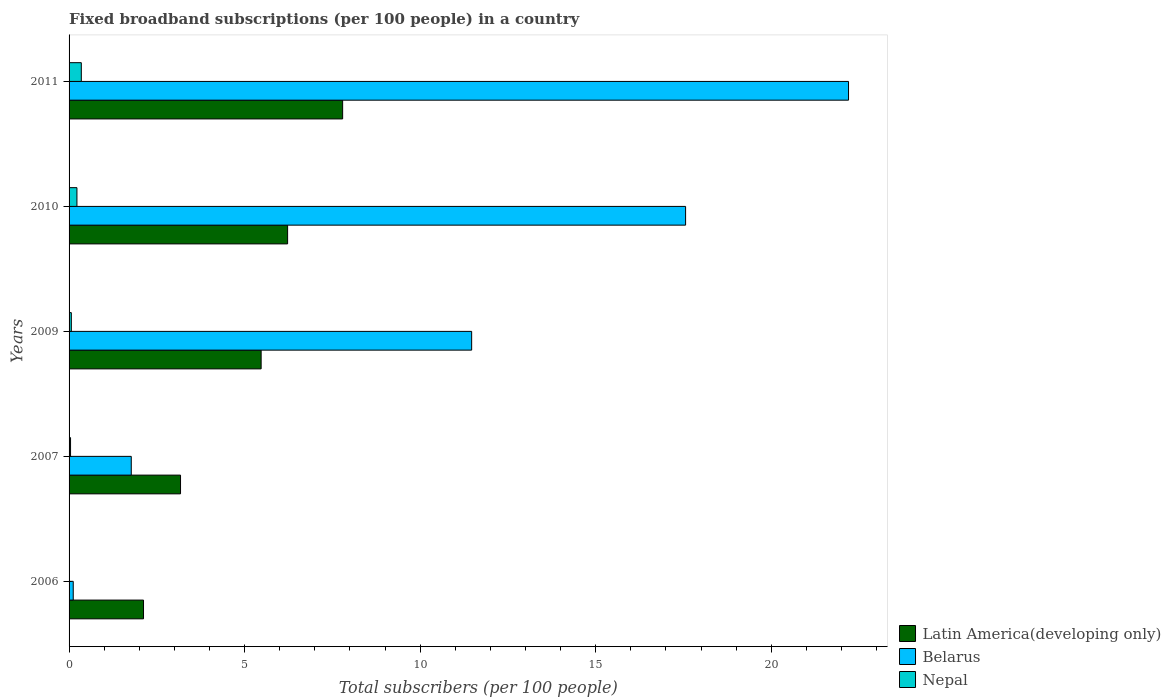How many groups of bars are there?
Ensure brevity in your answer.  5. How many bars are there on the 1st tick from the bottom?
Keep it short and to the point. 3. What is the label of the 5th group of bars from the top?
Ensure brevity in your answer.  2006. What is the number of broadband subscriptions in Nepal in 2011?
Keep it short and to the point. 0.35. Across all years, what is the maximum number of broadband subscriptions in Latin America(developing only)?
Give a very brief answer. 7.79. Across all years, what is the minimum number of broadband subscriptions in Nepal?
Make the answer very short. 0. In which year was the number of broadband subscriptions in Nepal minimum?
Give a very brief answer. 2006. What is the total number of broadband subscriptions in Latin America(developing only) in the graph?
Provide a short and direct response. 24.78. What is the difference between the number of broadband subscriptions in Latin America(developing only) in 2007 and that in 2009?
Your answer should be compact. -2.3. What is the difference between the number of broadband subscriptions in Belarus in 2010 and the number of broadband subscriptions in Nepal in 2006?
Offer a terse response. 17.56. What is the average number of broadband subscriptions in Belarus per year?
Your response must be concise. 10.62. In the year 2006, what is the difference between the number of broadband subscriptions in Belarus and number of broadband subscriptions in Nepal?
Your answer should be compact. 0.11. What is the ratio of the number of broadband subscriptions in Belarus in 2006 to that in 2011?
Ensure brevity in your answer.  0.01. What is the difference between the highest and the second highest number of broadband subscriptions in Latin America(developing only)?
Your answer should be compact. 1.57. What is the difference between the highest and the lowest number of broadband subscriptions in Nepal?
Your response must be concise. 0.34. In how many years, is the number of broadband subscriptions in Latin America(developing only) greater than the average number of broadband subscriptions in Latin America(developing only) taken over all years?
Your response must be concise. 3. What does the 1st bar from the top in 2010 represents?
Your answer should be very brief. Nepal. What does the 3rd bar from the bottom in 2010 represents?
Provide a succinct answer. Nepal. How many years are there in the graph?
Make the answer very short. 5. Are the values on the major ticks of X-axis written in scientific E-notation?
Offer a very short reply. No. Does the graph contain any zero values?
Make the answer very short. No. How many legend labels are there?
Offer a terse response. 3. How are the legend labels stacked?
Provide a short and direct response. Vertical. What is the title of the graph?
Your answer should be very brief. Fixed broadband subscriptions (per 100 people) in a country. What is the label or title of the X-axis?
Your answer should be compact. Total subscribers (per 100 people). What is the Total subscribers (per 100 people) in Latin America(developing only) in 2006?
Your answer should be very brief. 2.12. What is the Total subscribers (per 100 people) in Belarus in 2006?
Your answer should be very brief. 0.12. What is the Total subscribers (per 100 people) in Nepal in 2006?
Your response must be concise. 0. What is the Total subscribers (per 100 people) in Latin America(developing only) in 2007?
Your response must be concise. 3.17. What is the Total subscribers (per 100 people) in Belarus in 2007?
Offer a very short reply. 1.77. What is the Total subscribers (per 100 people) of Nepal in 2007?
Ensure brevity in your answer.  0.04. What is the Total subscribers (per 100 people) of Latin America(developing only) in 2009?
Your response must be concise. 5.47. What is the Total subscribers (per 100 people) of Belarus in 2009?
Provide a short and direct response. 11.47. What is the Total subscribers (per 100 people) in Nepal in 2009?
Ensure brevity in your answer.  0.06. What is the Total subscribers (per 100 people) of Latin America(developing only) in 2010?
Offer a terse response. 6.22. What is the Total subscribers (per 100 people) of Belarus in 2010?
Offer a very short reply. 17.56. What is the Total subscribers (per 100 people) in Nepal in 2010?
Provide a short and direct response. 0.22. What is the Total subscribers (per 100 people) in Latin America(developing only) in 2011?
Offer a terse response. 7.79. What is the Total subscribers (per 100 people) of Belarus in 2011?
Make the answer very short. 22.2. What is the Total subscribers (per 100 people) of Nepal in 2011?
Provide a succinct answer. 0.35. Across all years, what is the maximum Total subscribers (per 100 people) of Latin America(developing only)?
Keep it short and to the point. 7.79. Across all years, what is the maximum Total subscribers (per 100 people) in Belarus?
Offer a terse response. 22.2. Across all years, what is the maximum Total subscribers (per 100 people) in Nepal?
Provide a short and direct response. 0.35. Across all years, what is the minimum Total subscribers (per 100 people) in Latin America(developing only)?
Your response must be concise. 2.12. Across all years, what is the minimum Total subscribers (per 100 people) in Belarus?
Your answer should be compact. 0.12. Across all years, what is the minimum Total subscribers (per 100 people) in Nepal?
Make the answer very short. 0. What is the total Total subscribers (per 100 people) of Latin America(developing only) in the graph?
Make the answer very short. 24.78. What is the total Total subscribers (per 100 people) of Belarus in the graph?
Your answer should be compact. 53.12. What is the total Total subscribers (per 100 people) of Nepal in the graph?
Provide a short and direct response. 0.68. What is the difference between the Total subscribers (per 100 people) of Latin America(developing only) in 2006 and that in 2007?
Your response must be concise. -1.05. What is the difference between the Total subscribers (per 100 people) of Belarus in 2006 and that in 2007?
Your answer should be very brief. -1.65. What is the difference between the Total subscribers (per 100 people) of Nepal in 2006 and that in 2007?
Your response must be concise. -0.04. What is the difference between the Total subscribers (per 100 people) of Latin America(developing only) in 2006 and that in 2009?
Keep it short and to the point. -3.35. What is the difference between the Total subscribers (per 100 people) of Belarus in 2006 and that in 2009?
Provide a short and direct response. -11.35. What is the difference between the Total subscribers (per 100 people) of Nepal in 2006 and that in 2009?
Your answer should be very brief. -0.06. What is the difference between the Total subscribers (per 100 people) of Latin America(developing only) in 2006 and that in 2010?
Make the answer very short. -4.1. What is the difference between the Total subscribers (per 100 people) in Belarus in 2006 and that in 2010?
Offer a terse response. -17.44. What is the difference between the Total subscribers (per 100 people) of Nepal in 2006 and that in 2010?
Your response must be concise. -0.22. What is the difference between the Total subscribers (per 100 people) of Latin America(developing only) in 2006 and that in 2011?
Make the answer very short. -5.67. What is the difference between the Total subscribers (per 100 people) of Belarus in 2006 and that in 2011?
Keep it short and to the point. -22.08. What is the difference between the Total subscribers (per 100 people) in Nepal in 2006 and that in 2011?
Ensure brevity in your answer.  -0.34. What is the difference between the Total subscribers (per 100 people) in Latin America(developing only) in 2007 and that in 2009?
Your answer should be compact. -2.3. What is the difference between the Total subscribers (per 100 people) of Belarus in 2007 and that in 2009?
Ensure brevity in your answer.  -9.7. What is the difference between the Total subscribers (per 100 people) of Nepal in 2007 and that in 2009?
Offer a very short reply. -0.02. What is the difference between the Total subscribers (per 100 people) in Latin America(developing only) in 2007 and that in 2010?
Your response must be concise. -3.05. What is the difference between the Total subscribers (per 100 people) of Belarus in 2007 and that in 2010?
Your answer should be compact. -15.79. What is the difference between the Total subscribers (per 100 people) in Nepal in 2007 and that in 2010?
Your answer should be very brief. -0.18. What is the difference between the Total subscribers (per 100 people) of Latin America(developing only) in 2007 and that in 2011?
Ensure brevity in your answer.  -4.62. What is the difference between the Total subscribers (per 100 people) of Belarus in 2007 and that in 2011?
Keep it short and to the point. -20.43. What is the difference between the Total subscribers (per 100 people) in Nepal in 2007 and that in 2011?
Offer a terse response. -0.31. What is the difference between the Total subscribers (per 100 people) in Latin America(developing only) in 2009 and that in 2010?
Offer a very short reply. -0.75. What is the difference between the Total subscribers (per 100 people) in Belarus in 2009 and that in 2010?
Provide a short and direct response. -6.09. What is the difference between the Total subscribers (per 100 people) in Nepal in 2009 and that in 2010?
Give a very brief answer. -0.16. What is the difference between the Total subscribers (per 100 people) in Latin America(developing only) in 2009 and that in 2011?
Make the answer very short. -2.32. What is the difference between the Total subscribers (per 100 people) in Belarus in 2009 and that in 2011?
Keep it short and to the point. -10.73. What is the difference between the Total subscribers (per 100 people) in Nepal in 2009 and that in 2011?
Keep it short and to the point. -0.28. What is the difference between the Total subscribers (per 100 people) in Latin America(developing only) in 2010 and that in 2011?
Your response must be concise. -1.57. What is the difference between the Total subscribers (per 100 people) of Belarus in 2010 and that in 2011?
Your answer should be compact. -4.64. What is the difference between the Total subscribers (per 100 people) in Nepal in 2010 and that in 2011?
Offer a terse response. -0.12. What is the difference between the Total subscribers (per 100 people) in Latin America(developing only) in 2006 and the Total subscribers (per 100 people) in Belarus in 2007?
Ensure brevity in your answer.  0.35. What is the difference between the Total subscribers (per 100 people) in Latin America(developing only) in 2006 and the Total subscribers (per 100 people) in Nepal in 2007?
Your response must be concise. 2.08. What is the difference between the Total subscribers (per 100 people) in Belarus in 2006 and the Total subscribers (per 100 people) in Nepal in 2007?
Provide a short and direct response. 0.08. What is the difference between the Total subscribers (per 100 people) of Latin America(developing only) in 2006 and the Total subscribers (per 100 people) of Belarus in 2009?
Give a very brief answer. -9.35. What is the difference between the Total subscribers (per 100 people) of Latin America(developing only) in 2006 and the Total subscribers (per 100 people) of Nepal in 2009?
Your response must be concise. 2.06. What is the difference between the Total subscribers (per 100 people) of Belarus in 2006 and the Total subscribers (per 100 people) of Nepal in 2009?
Provide a short and direct response. 0.05. What is the difference between the Total subscribers (per 100 people) in Latin America(developing only) in 2006 and the Total subscribers (per 100 people) in Belarus in 2010?
Keep it short and to the point. -15.44. What is the difference between the Total subscribers (per 100 people) in Latin America(developing only) in 2006 and the Total subscribers (per 100 people) in Nepal in 2010?
Offer a terse response. 1.9. What is the difference between the Total subscribers (per 100 people) of Belarus in 2006 and the Total subscribers (per 100 people) of Nepal in 2010?
Provide a short and direct response. -0.11. What is the difference between the Total subscribers (per 100 people) in Latin America(developing only) in 2006 and the Total subscribers (per 100 people) in Belarus in 2011?
Offer a terse response. -20.08. What is the difference between the Total subscribers (per 100 people) of Latin America(developing only) in 2006 and the Total subscribers (per 100 people) of Nepal in 2011?
Provide a succinct answer. 1.77. What is the difference between the Total subscribers (per 100 people) in Belarus in 2006 and the Total subscribers (per 100 people) in Nepal in 2011?
Your response must be concise. -0.23. What is the difference between the Total subscribers (per 100 people) of Latin America(developing only) in 2007 and the Total subscribers (per 100 people) of Belarus in 2009?
Your answer should be compact. -8.29. What is the difference between the Total subscribers (per 100 people) of Latin America(developing only) in 2007 and the Total subscribers (per 100 people) of Nepal in 2009?
Give a very brief answer. 3.11. What is the difference between the Total subscribers (per 100 people) of Belarus in 2007 and the Total subscribers (per 100 people) of Nepal in 2009?
Provide a short and direct response. 1.71. What is the difference between the Total subscribers (per 100 people) in Latin America(developing only) in 2007 and the Total subscribers (per 100 people) in Belarus in 2010?
Provide a succinct answer. -14.39. What is the difference between the Total subscribers (per 100 people) in Latin America(developing only) in 2007 and the Total subscribers (per 100 people) in Nepal in 2010?
Make the answer very short. 2.95. What is the difference between the Total subscribers (per 100 people) in Belarus in 2007 and the Total subscribers (per 100 people) in Nepal in 2010?
Keep it short and to the point. 1.55. What is the difference between the Total subscribers (per 100 people) in Latin America(developing only) in 2007 and the Total subscribers (per 100 people) in Belarus in 2011?
Your response must be concise. -19.03. What is the difference between the Total subscribers (per 100 people) of Latin America(developing only) in 2007 and the Total subscribers (per 100 people) of Nepal in 2011?
Make the answer very short. 2.83. What is the difference between the Total subscribers (per 100 people) in Belarus in 2007 and the Total subscribers (per 100 people) in Nepal in 2011?
Your response must be concise. 1.42. What is the difference between the Total subscribers (per 100 people) of Latin America(developing only) in 2009 and the Total subscribers (per 100 people) of Belarus in 2010?
Make the answer very short. -12.09. What is the difference between the Total subscribers (per 100 people) in Latin America(developing only) in 2009 and the Total subscribers (per 100 people) in Nepal in 2010?
Provide a short and direct response. 5.25. What is the difference between the Total subscribers (per 100 people) in Belarus in 2009 and the Total subscribers (per 100 people) in Nepal in 2010?
Your response must be concise. 11.24. What is the difference between the Total subscribers (per 100 people) in Latin America(developing only) in 2009 and the Total subscribers (per 100 people) in Belarus in 2011?
Make the answer very short. -16.73. What is the difference between the Total subscribers (per 100 people) in Latin America(developing only) in 2009 and the Total subscribers (per 100 people) in Nepal in 2011?
Provide a short and direct response. 5.12. What is the difference between the Total subscribers (per 100 people) of Belarus in 2009 and the Total subscribers (per 100 people) of Nepal in 2011?
Provide a short and direct response. 11.12. What is the difference between the Total subscribers (per 100 people) in Latin America(developing only) in 2010 and the Total subscribers (per 100 people) in Belarus in 2011?
Offer a terse response. -15.98. What is the difference between the Total subscribers (per 100 people) in Latin America(developing only) in 2010 and the Total subscribers (per 100 people) in Nepal in 2011?
Keep it short and to the point. 5.88. What is the difference between the Total subscribers (per 100 people) in Belarus in 2010 and the Total subscribers (per 100 people) in Nepal in 2011?
Provide a succinct answer. 17.21. What is the average Total subscribers (per 100 people) of Latin America(developing only) per year?
Offer a very short reply. 4.96. What is the average Total subscribers (per 100 people) of Belarus per year?
Give a very brief answer. 10.62. What is the average Total subscribers (per 100 people) in Nepal per year?
Make the answer very short. 0.14. In the year 2006, what is the difference between the Total subscribers (per 100 people) in Latin America(developing only) and Total subscribers (per 100 people) in Belarus?
Ensure brevity in your answer.  2. In the year 2006, what is the difference between the Total subscribers (per 100 people) of Latin America(developing only) and Total subscribers (per 100 people) of Nepal?
Offer a terse response. 2.12. In the year 2006, what is the difference between the Total subscribers (per 100 people) of Belarus and Total subscribers (per 100 people) of Nepal?
Your answer should be very brief. 0.11. In the year 2007, what is the difference between the Total subscribers (per 100 people) in Latin America(developing only) and Total subscribers (per 100 people) in Belarus?
Provide a succinct answer. 1.4. In the year 2007, what is the difference between the Total subscribers (per 100 people) in Latin America(developing only) and Total subscribers (per 100 people) in Nepal?
Offer a terse response. 3.13. In the year 2007, what is the difference between the Total subscribers (per 100 people) in Belarus and Total subscribers (per 100 people) in Nepal?
Your response must be concise. 1.73. In the year 2009, what is the difference between the Total subscribers (per 100 people) of Latin America(developing only) and Total subscribers (per 100 people) of Belarus?
Make the answer very short. -6. In the year 2009, what is the difference between the Total subscribers (per 100 people) in Latin America(developing only) and Total subscribers (per 100 people) in Nepal?
Keep it short and to the point. 5.41. In the year 2009, what is the difference between the Total subscribers (per 100 people) in Belarus and Total subscribers (per 100 people) in Nepal?
Provide a short and direct response. 11.4. In the year 2010, what is the difference between the Total subscribers (per 100 people) in Latin America(developing only) and Total subscribers (per 100 people) in Belarus?
Your response must be concise. -11.34. In the year 2010, what is the difference between the Total subscribers (per 100 people) in Latin America(developing only) and Total subscribers (per 100 people) in Nepal?
Your response must be concise. 6. In the year 2010, what is the difference between the Total subscribers (per 100 people) of Belarus and Total subscribers (per 100 people) of Nepal?
Your answer should be very brief. 17.34. In the year 2011, what is the difference between the Total subscribers (per 100 people) in Latin America(developing only) and Total subscribers (per 100 people) in Belarus?
Offer a very short reply. -14.41. In the year 2011, what is the difference between the Total subscribers (per 100 people) in Latin America(developing only) and Total subscribers (per 100 people) in Nepal?
Your answer should be compact. 7.44. In the year 2011, what is the difference between the Total subscribers (per 100 people) of Belarus and Total subscribers (per 100 people) of Nepal?
Keep it short and to the point. 21.85. What is the ratio of the Total subscribers (per 100 people) in Latin America(developing only) in 2006 to that in 2007?
Make the answer very short. 0.67. What is the ratio of the Total subscribers (per 100 people) in Belarus in 2006 to that in 2007?
Provide a succinct answer. 0.07. What is the ratio of the Total subscribers (per 100 people) of Nepal in 2006 to that in 2007?
Offer a very short reply. 0.09. What is the ratio of the Total subscribers (per 100 people) in Latin America(developing only) in 2006 to that in 2009?
Offer a terse response. 0.39. What is the ratio of the Total subscribers (per 100 people) in Belarus in 2006 to that in 2009?
Give a very brief answer. 0.01. What is the ratio of the Total subscribers (per 100 people) in Nepal in 2006 to that in 2009?
Make the answer very short. 0.06. What is the ratio of the Total subscribers (per 100 people) of Latin America(developing only) in 2006 to that in 2010?
Your answer should be compact. 0.34. What is the ratio of the Total subscribers (per 100 people) in Belarus in 2006 to that in 2010?
Offer a very short reply. 0.01. What is the ratio of the Total subscribers (per 100 people) of Nepal in 2006 to that in 2010?
Keep it short and to the point. 0.02. What is the ratio of the Total subscribers (per 100 people) of Latin America(developing only) in 2006 to that in 2011?
Your response must be concise. 0.27. What is the ratio of the Total subscribers (per 100 people) in Belarus in 2006 to that in 2011?
Make the answer very short. 0.01. What is the ratio of the Total subscribers (per 100 people) in Nepal in 2006 to that in 2011?
Give a very brief answer. 0.01. What is the ratio of the Total subscribers (per 100 people) of Latin America(developing only) in 2007 to that in 2009?
Make the answer very short. 0.58. What is the ratio of the Total subscribers (per 100 people) in Belarus in 2007 to that in 2009?
Your answer should be compact. 0.15. What is the ratio of the Total subscribers (per 100 people) in Nepal in 2007 to that in 2009?
Your answer should be very brief. 0.66. What is the ratio of the Total subscribers (per 100 people) of Latin America(developing only) in 2007 to that in 2010?
Ensure brevity in your answer.  0.51. What is the ratio of the Total subscribers (per 100 people) in Belarus in 2007 to that in 2010?
Offer a terse response. 0.1. What is the ratio of the Total subscribers (per 100 people) in Nepal in 2007 to that in 2010?
Offer a terse response. 0.19. What is the ratio of the Total subscribers (per 100 people) of Latin America(developing only) in 2007 to that in 2011?
Give a very brief answer. 0.41. What is the ratio of the Total subscribers (per 100 people) of Belarus in 2007 to that in 2011?
Give a very brief answer. 0.08. What is the ratio of the Total subscribers (per 100 people) in Nepal in 2007 to that in 2011?
Provide a short and direct response. 0.12. What is the ratio of the Total subscribers (per 100 people) in Latin America(developing only) in 2009 to that in 2010?
Offer a very short reply. 0.88. What is the ratio of the Total subscribers (per 100 people) of Belarus in 2009 to that in 2010?
Your response must be concise. 0.65. What is the ratio of the Total subscribers (per 100 people) of Nepal in 2009 to that in 2010?
Provide a succinct answer. 0.29. What is the ratio of the Total subscribers (per 100 people) in Latin America(developing only) in 2009 to that in 2011?
Your response must be concise. 0.7. What is the ratio of the Total subscribers (per 100 people) of Belarus in 2009 to that in 2011?
Offer a very short reply. 0.52. What is the ratio of the Total subscribers (per 100 people) in Nepal in 2009 to that in 2011?
Your answer should be very brief. 0.18. What is the ratio of the Total subscribers (per 100 people) in Latin America(developing only) in 2010 to that in 2011?
Provide a short and direct response. 0.8. What is the ratio of the Total subscribers (per 100 people) of Belarus in 2010 to that in 2011?
Make the answer very short. 0.79. What is the ratio of the Total subscribers (per 100 people) in Nepal in 2010 to that in 2011?
Your answer should be very brief. 0.64. What is the difference between the highest and the second highest Total subscribers (per 100 people) in Latin America(developing only)?
Your response must be concise. 1.57. What is the difference between the highest and the second highest Total subscribers (per 100 people) of Belarus?
Your answer should be compact. 4.64. What is the difference between the highest and the second highest Total subscribers (per 100 people) in Nepal?
Your response must be concise. 0.12. What is the difference between the highest and the lowest Total subscribers (per 100 people) of Latin America(developing only)?
Your answer should be very brief. 5.67. What is the difference between the highest and the lowest Total subscribers (per 100 people) in Belarus?
Ensure brevity in your answer.  22.08. What is the difference between the highest and the lowest Total subscribers (per 100 people) of Nepal?
Make the answer very short. 0.34. 